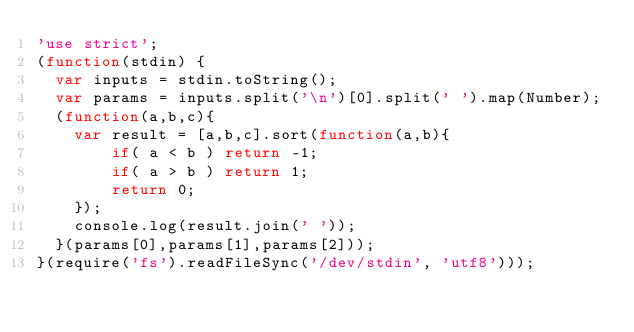<code> <loc_0><loc_0><loc_500><loc_500><_JavaScript_>'use strict';
(function(stdin) { 
  var inputs = stdin.toString();
  var params = inputs.split('\n')[0].split(' ').map(Number);
  (function(a,b,c){
    var result = [a,b,c].sort(function(a,b){
        if( a < b ) return -1;
        if( a > b ) return 1;
        return 0;
    });
    console.log(result.join(' '));
  }(params[0],params[1],params[2])); 
}(require('fs').readFileSync('/dev/stdin', 'utf8')));</code> 